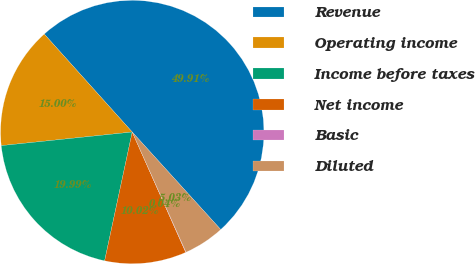Convert chart. <chart><loc_0><loc_0><loc_500><loc_500><pie_chart><fcel>Revenue<fcel>Operating income<fcel>Income before taxes<fcel>Net income<fcel>Basic<fcel>Diluted<nl><fcel>49.91%<fcel>15.0%<fcel>19.99%<fcel>10.02%<fcel>0.04%<fcel>5.03%<nl></chart> 